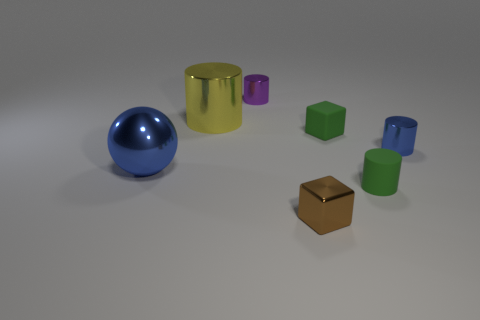The small purple thing that is made of the same material as the blue cylinder is what shape?
Make the answer very short. Cylinder. Is the number of tiny blue shiny things that are in front of the small brown thing the same as the number of small purple objects?
Your response must be concise. No. Does the blue thing that is on the left side of the purple metallic thing have the same material as the tiny cylinder behind the tiny blue shiny thing?
Offer a very short reply. Yes. There is a blue object left of the small shiny cylinder that is on the left side of the green cube; what is its shape?
Ensure brevity in your answer.  Sphere. There is a large sphere that is made of the same material as the small brown cube; what color is it?
Keep it short and to the point. Blue. Do the ball and the tiny metal block have the same color?
Give a very brief answer. No. There is a purple object that is the same size as the brown shiny object; what is its shape?
Give a very brief answer. Cylinder. The purple cylinder is what size?
Provide a short and direct response. Small. Is the size of the blue object that is behind the large blue ball the same as the blue metallic thing that is on the left side of the tiny purple metallic cylinder?
Make the answer very short. No. There is a cylinder that is on the left side of the tiny metal object behind the blue cylinder; what color is it?
Ensure brevity in your answer.  Yellow. 